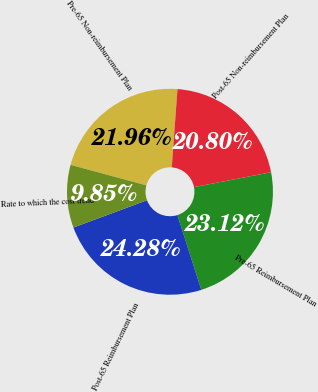Convert chart to OTSL. <chart><loc_0><loc_0><loc_500><loc_500><pie_chart><fcel>Pre-65 Non-reimbursement Plan<fcel>Post-65 Non-reimbursement Plan<fcel>Pre-65 Reimbursement Plan<fcel>Post-65 Reimbursement Plan<fcel>Rate to which the cost trend<nl><fcel>21.96%<fcel>20.8%<fcel>23.12%<fcel>24.28%<fcel>9.85%<nl></chart> 